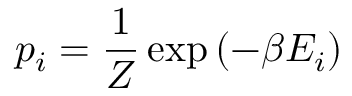Convert formula to latex. <formula><loc_0><loc_0><loc_500><loc_500>p _ { i } = \frac { 1 } { Z } \exp \left ( { - \beta E _ { i } } \right )</formula> 